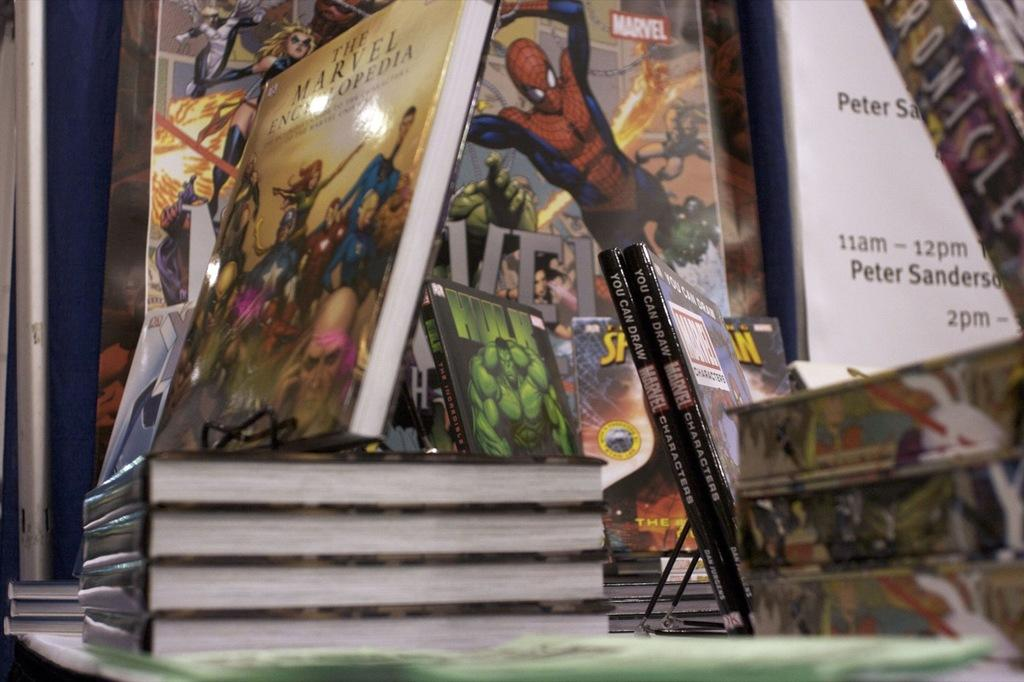<image>
Render a clear and concise summary of the photo. The Marvel Encyclopedia sits on a surface with several other comics. 